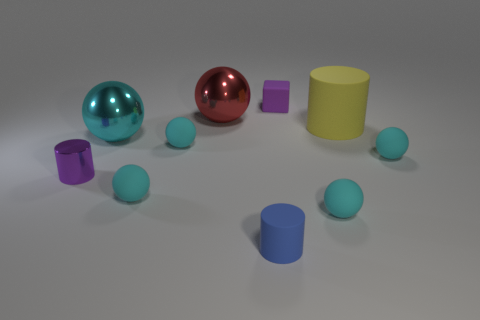What is the material of the tiny purple thing that is on the right side of the purple thing on the left side of the small block?
Provide a short and direct response. Rubber. Are there any matte blocks of the same color as the tiny matte cylinder?
Ensure brevity in your answer.  No. The blue cylinder that is made of the same material as the yellow cylinder is what size?
Make the answer very short. Small. Are there any other things of the same color as the tiny rubber cylinder?
Give a very brief answer. No. The big shiny sphere that is behind the yellow rubber thing is what color?
Make the answer very short. Red. Is there a cyan thing that is behind the big ball behind the matte cylinder on the right side of the tiny cube?
Ensure brevity in your answer.  No. Are there more tiny rubber objects that are behind the small metallic cylinder than tiny cyan rubber things?
Keep it short and to the point. No. Does the big thing that is to the right of the purple block have the same shape as the large cyan object?
Give a very brief answer. No. Is there any other thing that is made of the same material as the big cyan sphere?
Keep it short and to the point. Yes. How many objects are cylinders or tiny cyan things to the right of the small purple matte thing?
Offer a very short reply. 5. 